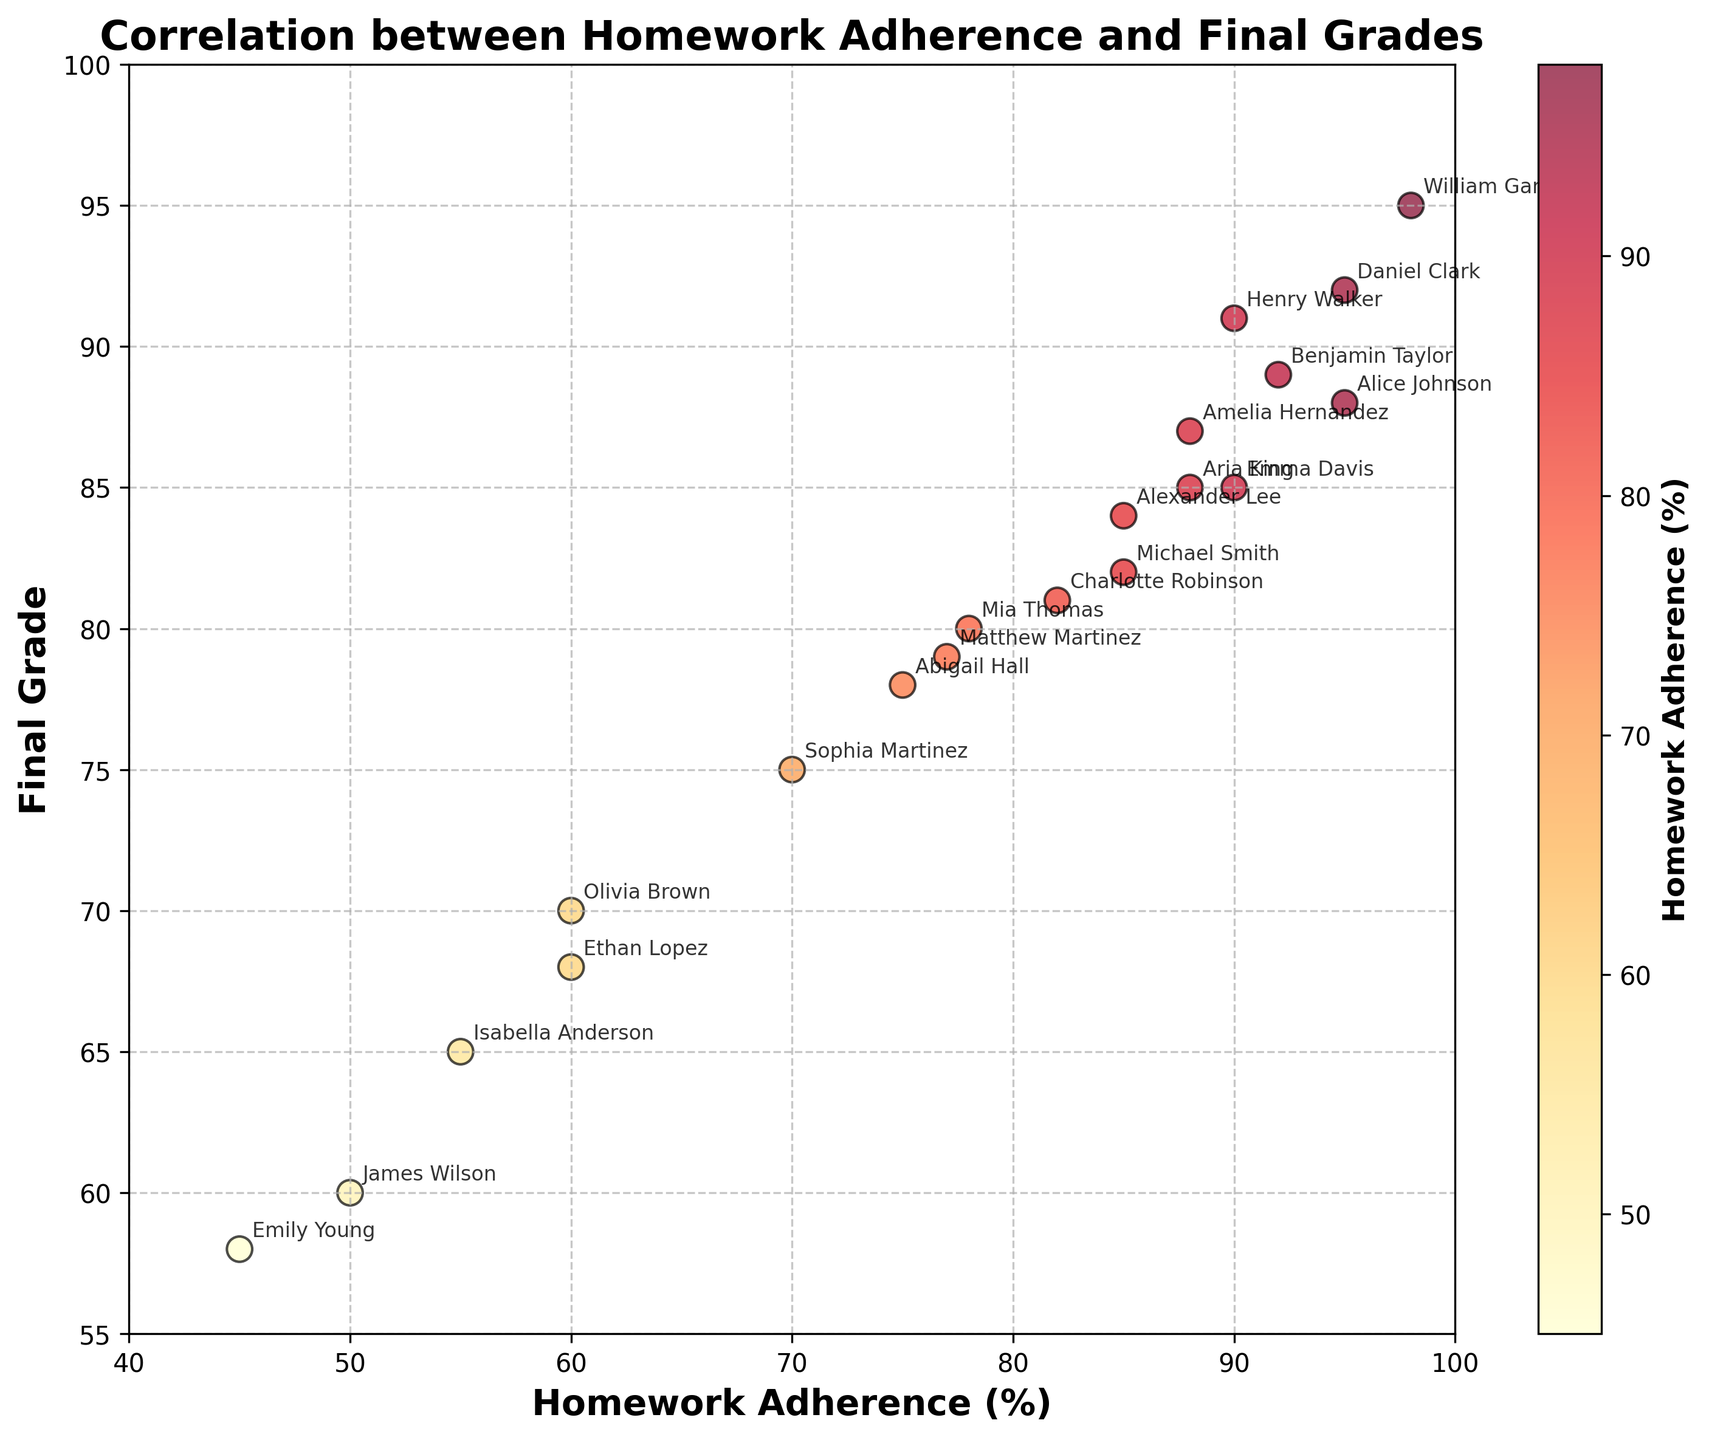What is the title of the plot? The title of the plot is displayed at the top of the figure.
Answer: Correlation between Homework Adherence and Final Grades What is represented by the x-axis? The x-axis label, found at the bottom of the plot, indicates what is being measured along this axis.
Answer: Homework Adherence (%) Who is the student with the highest homework adherence, and what is their final grade? By looking at the data points and annotations, identify the student with the highest value along the x-axis and reference their corresponding y-axis value.
Answer: William Garcia, 95 Which student has the lowest final grade, and what is their homework adherence percentage? Check the data points and annotations to find the student with the lowest y-axis value and note their x-axis value.
Answer: Emily Young, 45 Is there a general trend between homework adherence and final grades? Observe the overall distribution and direction of the data points in the scatter plot.
Answer: Positive correlation Between Michael Smith and Alexander Lee, who has a higher final grade? Compare the y-axis values of the data points associated with Michael Smith and Alexander Lee.
Answer: Alexander Lee Who has a higher final grade: Olivia Brown or Sophia Martinez? Locate the positions of Olivia Brown and Sophia Martinez on the y-axis and compare their values.
Answer: Sophia Martinez What is the approximate final grade for someone with 90% homework adherence? Check the y-axis value directly above or closest to the 90% mark on the x-axis.
Answer: 85-91 How many students have a homework adherence percentage above 90%? Count the number of data points where the x-axis value is greater than 90.
Answer: 4 What's the difference in final grades between the students with the highest and lowest homework adherence? Identify the final grades for the highest and lowest homework adherence, then compute the difference.
Answer: 37 (95 - 58) Which student shows the greatest disparity between homework adherence and final grade? Look for the student with the largest vertical distance from a likely trend line between homework adherence and final grades.
Answer: Emily Young 